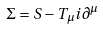<formula> <loc_0><loc_0><loc_500><loc_500>\Sigma = S - T _ { \mu } i \partial ^ { \mu }</formula> 